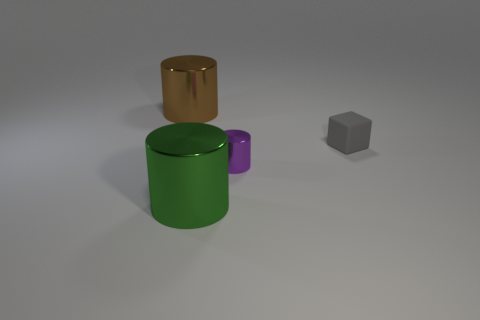Are there any other things that have the same material as the gray object?
Make the answer very short. No. Are there any other things that have the same material as the large green object?
Your answer should be very brief. Yes. There is a object that is both behind the tiny purple metallic thing and right of the brown metallic object; what is its shape?
Offer a very short reply. Cube. What number of large objects are either blue shiny cubes or brown metallic cylinders?
Keep it short and to the point. 1. What is the small block made of?
Your response must be concise. Rubber. How many other objects are the same shape as the big green metallic object?
Your response must be concise. 2. How big is the block?
Ensure brevity in your answer.  Small. There is a object that is right of the large green metallic thing and in front of the matte block; what size is it?
Make the answer very short. Small. What shape is the large thing behind the purple metal cylinder?
Your response must be concise. Cylinder. Is the material of the green object the same as the tiny thing behind the purple metallic thing?
Keep it short and to the point. No. 